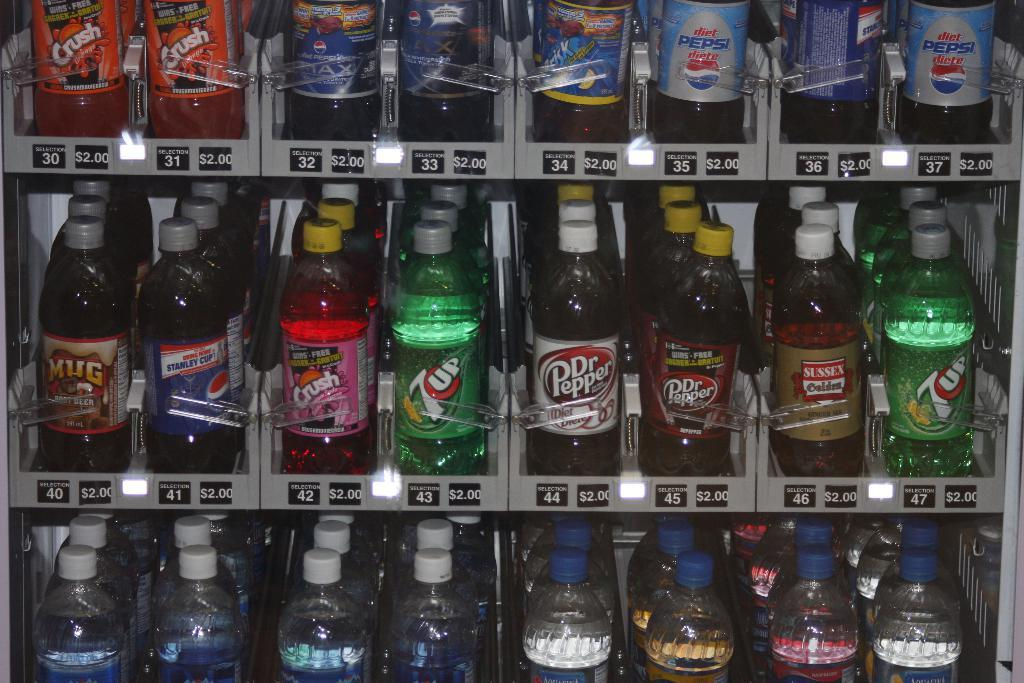Provide a one-sentence caption for the provided image. A dispenser machine with different products, 3 rows can be seen and among the products are 7up, Dr. Pepper, Pepsi and other soda products, also water. 